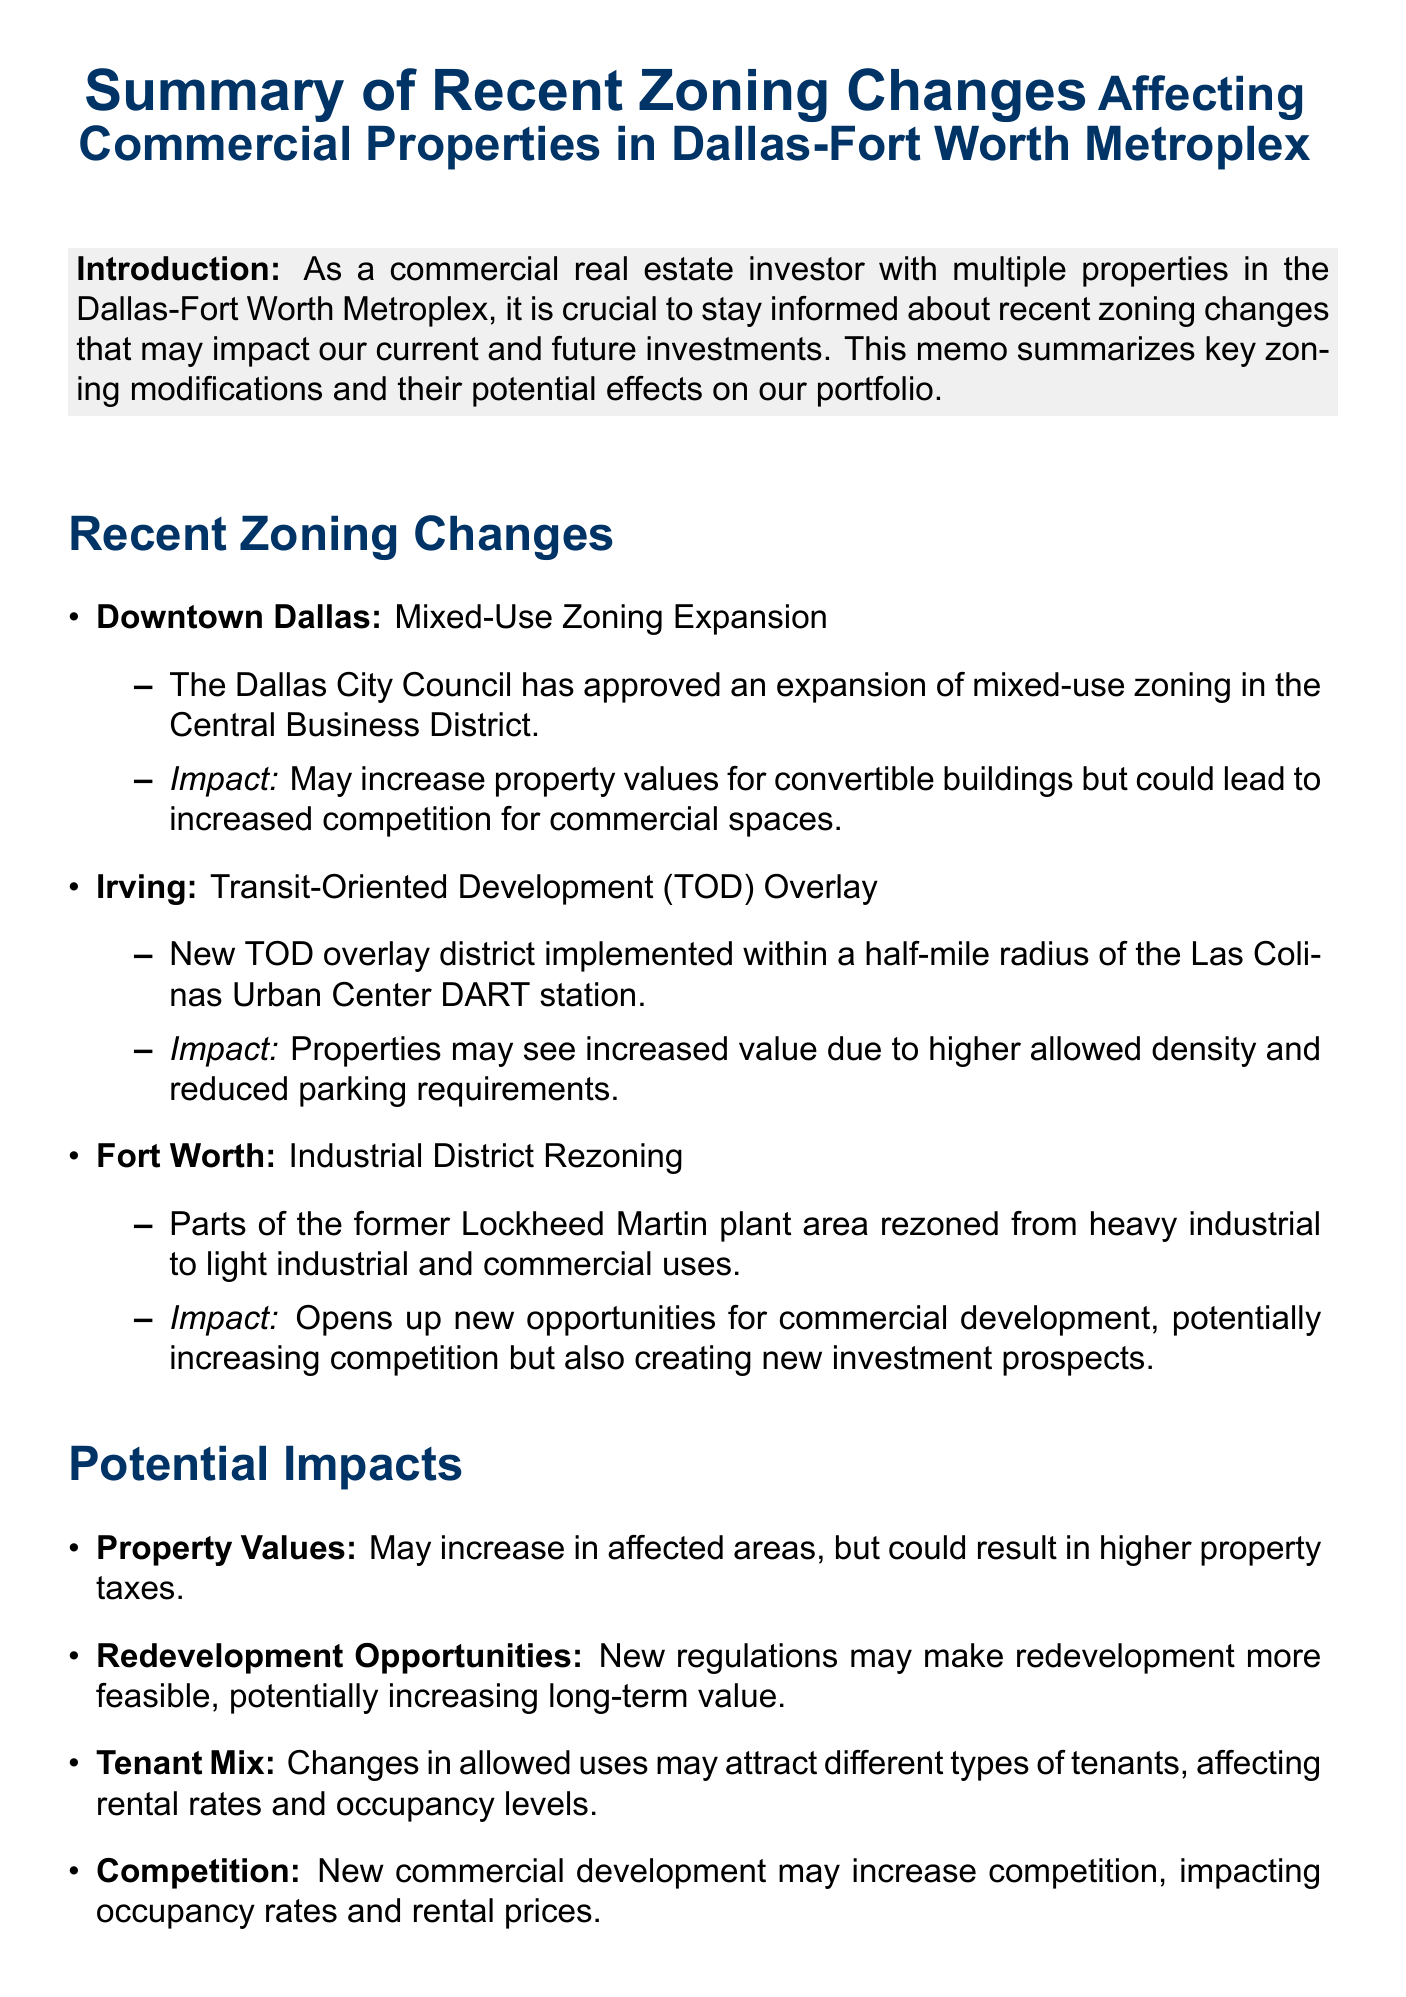What area is undergoing mixed-use zoning expansion? The area mentioned for mixed-use zoning expansion is Downtown Dallas in the document.
Answer: Downtown Dallas What overlay district has been implemented in Irving? The document states that a Transit-Oriented Development (TOD) overlay has been implemented in Irving.
Answer: Transit-Oriented Development (TOD) Overlay What potential impact is mentioned for property values due to zoning changes? The potential impact on property values due to zoning changes is an increase in affected areas but could result in higher property taxes as noted in the document.
Answer: Increased property values What is a recommended action regarding the property portfolio? One of the recommended actions is to review the current property portfolio to identify affected assets.
Answer: Review current property portfolio What type of zoning change occurred in Fort Worth? The document describes the change in Fort Worth as Industrial District Rezoning.
Answer: Industrial District Rezoning How might zoning changes affect tenant mix? The document indicates that changes in allowed uses may attract different types of tenants, which could affect rental rates and occupancy levels.
Answer: Attract different types of tenants What is one potential redevelopment opportunity mentioned? The document states that new zoning regulations may make it more feasible to redevelop existing properties.
Answer: More feasible to redevelop existing properties What is one challenge presented by recent zoning changes? The document mentions increased competition in certain areas as a challenge posed by recent zoning changes.
Answer: Increased competition 